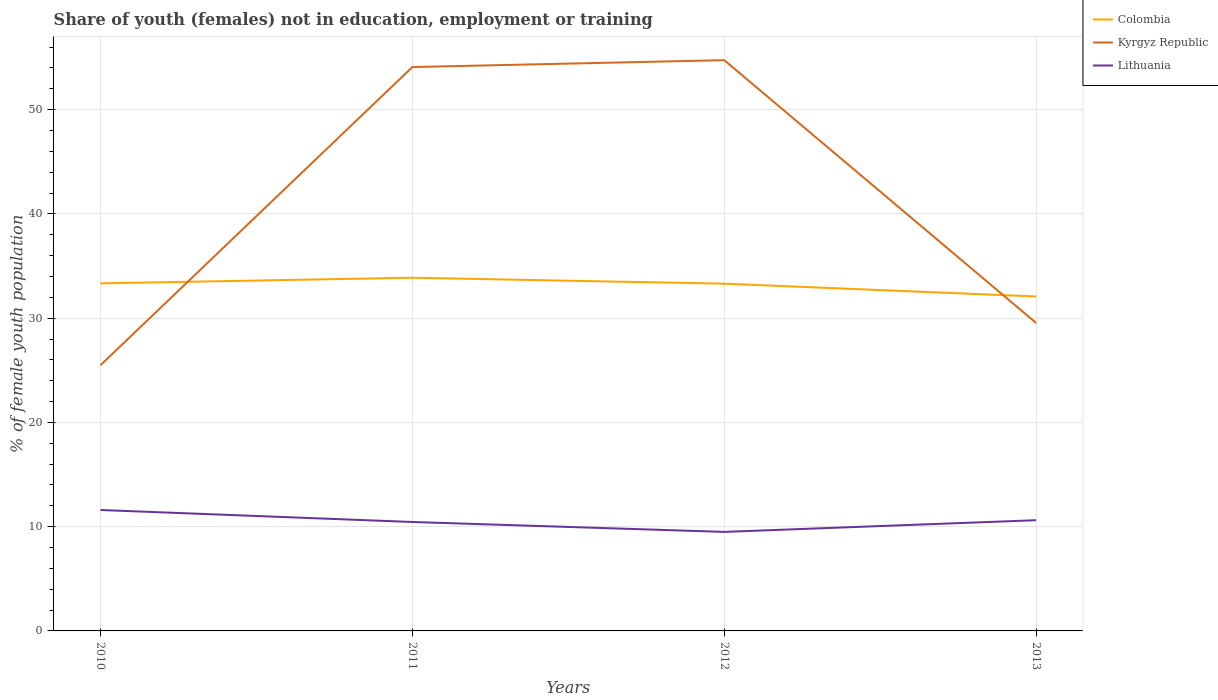How many different coloured lines are there?
Offer a very short reply. 3. Does the line corresponding to Kyrgyz Republic intersect with the line corresponding to Colombia?
Keep it short and to the point. Yes. Is the number of lines equal to the number of legend labels?
Your answer should be very brief. Yes. What is the total percentage of unemployed female population in in Lithuania in the graph?
Your answer should be compact. 1.15. What is the difference between the highest and the second highest percentage of unemployed female population in in Colombia?
Your response must be concise. 1.8. How many years are there in the graph?
Give a very brief answer. 4. Does the graph contain grids?
Offer a very short reply. Yes. How many legend labels are there?
Provide a succinct answer. 3. What is the title of the graph?
Your answer should be compact. Share of youth (females) not in education, employment or training. Does "Sweden" appear as one of the legend labels in the graph?
Your answer should be compact. No. What is the label or title of the Y-axis?
Ensure brevity in your answer.  % of female youth population. What is the % of female youth population of Colombia in 2010?
Offer a very short reply. 33.34. What is the % of female youth population in Kyrgyz Republic in 2010?
Give a very brief answer. 25.49. What is the % of female youth population in Lithuania in 2010?
Provide a succinct answer. 11.6. What is the % of female youth population in Colombia in 2011?
Keep it short and to the point. 33.88. What is the % of female youth population of Kyrgyz Republic in 2011?
Keep it short and to the point. 54.09. What is the % of female youth population of Lithuania in 2011?
Ensure brevity in your answer.  10.45. What is the % of female youth population of Colombia in 2012?
Provide a short and direct response. 33.31. What is the % of female youth population of Kyrgyz Republic in 2012?
Give a very brief answer. 54.75. What is the % of female youth population in Lithuania in 2012?
Offer a very short reply. 9.5. What is the % of female youth population in Colombia in 2013?
Your answer should be compact. 32.08. What is the % of female youth population in Kyrgyz Republic in 2013?
Your answer should be very brief. 29.54. What is the % of female youth population of Lithuania in 2013?
Keep it short and to the point. 10.62. Across all years, what is the maximum % of female youth population of Colombia?
Ensure brevity in your answer.  33.88. Across all years, what is the maximum % of female youth population of Kyrgyz Republic?
Provide a short and direct response. 54.75. Across all years, what is the maximum % of female youth population of Lithuania?
Keep it short and to the point. 11.6. Across all years, what is the minimum % of female youth population of Colombia?
Your answer should be compact. 32.08. Across all years, what is the minimum % of female youth population of Kyrgyz Republic?
Offer a terse response. 25.49. Across all years, what is the minimum % of female youth population in Lithuania?
Your response must be concise. 9.5. What is the total % of female youth population of Colombia in the graph?
Give a very brief answer. 132.61. What is the total % of female youth population in Kyrgyz Republic in the graph?
Provide a succinct answer. 163.87. What is the total % of female youth population of Lithuania in the graph?
Make the answer very short. 42.17. What is the difference between the % of female youth population in Colombia in 2010 and that in 2011?
Make the answer very short. -0.54. What is the difference between the % of female youth population in Kyrgyz Republic in 2010 and that in 2011?
Give a very brief answer. -28.6. What is the difference between the % of female youth population of Lithuania in 2010 and that in 2011?
Make the answer very short. 1.15. What is the difference between the % of female youth population of Colombia in 2010 and that in 2012?
Provide a short and direct response. 0.03. What is the difference between the % of female youth population of Kyrgyz Republic in 2010 and that in 2012?
Make the answer very short. -29.26. What is the difference between the % of female youth population of Lithuania in 2010 and that in 2012?
Offer a terse response. 2.1. What is the difference between the % of female youth population of Colombia in 2010 and that in 2013?
Offer a terse response. 1.26. What is the difference between the % of female youth population of Kyrgyz Republic in 2010 and that in 2013?
Your response must be concise. -4.05. What is the difference between the % of female youth population of Lithuania in 2010 and that in 2013?
Your response must be concise. 0.98. What is the difference between the % of female youth population in Colombia in 2011 and that in 2012?
Keep it short and to the point. 0.57. What is the difference between the % of female youth population in Kyrgyz Republic in 2011 and that in 2012?
Make the answer very short. -0.66. What is the difference between the % of female youth population of Lithuania in 2011 and that in 2012?
Your answer should be compact. 0.95. What is the difference between the % of female youth population of Kyrgyz Republic in 2011 and that in 2013?
Keep it short and to the point. 24.55. What is the difference between the % of female youth population in Lithuania in 2011 and that in 2013?
Your answer should be very brief. -0.17. What is the difference between the % of female youth population in Colombia in 2012 and that in 2013?
Offer a terse response. 1.23. What is the difference between the % of female youth population of Kyrgyz Republic in 2012 and that in 2013?
Your response must be concise. 25.21. What is the difference between the % of female youth population of Lithuania in 2012 and that in 2013?
Your answer should be compact. -1.12. What is the difference between the % of female youth population in Colombia in 2010 and the % of female youth population in Kyrgyz Republic in 2011?
Give a very brief answer. -20.75. What is the difference between the % of female youth population in Colombia in 2010 and the % of female youth population in Lithuania in 2011?
Provide a succinct answer. 22.89. What is the difference between the % of female youth population in Kyrgyz Republic in 2010 and the % of female youth population in Lithuania in 2011?
Your answer should be very brief. 15.04. What is the difference between the % of female youth population of Colombia in 2010 and the % of female youth population of Kyrgyz Republic in 2012?
Keep it short and to the point. -21.41. What is the difference between the % of female youth population of Colombia in 2010 and the % of female youth population of Lithuania in 2012?
Provide a short and direct response. 23.84. What is the difference between the % of female youth population in Kyrgyz Republic in 2010 and the % of female youth population in Lithuania in 2012?
Keep it short and to the point. 15.99. What is the difference between the % of female youth population in Colombia in 2010 and the % of female youth population in Lithuania in 2013?
Offer a very short reply. 22.72. What is the difference between the % of female youth population of Kyrgyz Republic in 2010 and the % of female youth population of Lithuania in 2013?
Provide a short and direct response. 14.87. What is the difference between the % of female youth population in Colombia in 2011 and the % of female youth population in Kyrgyz Republic in 2012?
Your answer should be very brief. -20.87. What is the difference between the % of female youth population in Colombia in 2011 and the % of female youth population in Lithuania in 2012?
Offer a very short reply. 24.38. What is the difference between the % of female youth population of Kyrgyz Republic in 2011 and the % of female youth population of Lithuania in 2012?
Offer a very short reply. 44.59. What is the difference between the % of female youth population of Colombia in 2011 and the % of female youth population of Kyrgyz Republic in 2013?
Your answer should be very brief. 4.34. What is the difference between the % of female youth population of Colombia in 2011 and the % of female youth population of Lithuania in 2013?
Your answer should be very brief. 23.26. What is the difference between the % of female youth population of Kyrgyz Republic in 2011 and the % of female youth population of Lithuania in 2013?
Keep it short and to the point. 43.47. What is the difference between the % of female youth population of Colombia in 2012 and the % of female youth population of Kyrgyz Republic in 2013?
Keep it short and to the point. 3.77. What is the difference between the % of female youth population of Colombia in 2012 and the % of female youth population of Lithuania in 2013?
Your answer should be compact. 22.69. What is the difference between the % of female youth population in Kyrgyz Republic in 2012 and the % of female youth population in Lithuania in 2013?
Ensure brevity in your answer.  44.13. What is the average % of female youth population of Colombia per year?
Your answer should be very brief. 33.15. What is the average % of female youth population in Kyrgyz Republic per year?
Ensure brevity in your answer.  40.97. What is the average % of female youth population in Lithuania per year?
Offer a terse response. 10.54. In the year 2010, what is the difference between the % of female youth population in Colombia and % of female youth population in Kyrgyz Republic?
Make the answer very short. 7.85. In the year 2010, what is the difference between the % of female youth population of Colombia and % of female youth population of Lithuania?
Ensure brevity in your answer.  21.74. In the year 2010, what is the difference between the % of female youth population in Kyrgyz Republic and % of female youth population in Lithuania?
Your answer should be compact. 13.89. In the year 2011, what is the difference between the % of female youth population in Colombia and % of female youth population in Kyrgyz Republic?
Provide a succinct answer. -20.21. In the year 2011, what is the difference between the % of female youth population of Colombia and % of female youth population of Lithuania?
Provide a succinct answer. 23.43. In the year 2011, what is the difference between the % of female youth population in Kyrgyz Republic and % of female youth population in Lithuania?
Provide a succinct answer. 43.64. In the year 2012, what is the difference between the % of female youth population of Colombia and % of female youth population of Kyrgyz Republic?
Give a very brief answer. -21.44. In the year 2012, what is the difference between the % of female youth population in Colombia and % of female youth population in Lithuania?
Your answer should be compact. 23.81. In the year 2012, what is the difference between the % of female youth population of Kyrgyz Republic and % of female youth population of Lithuania?
Make the answer very short. 45.25. In the year 2013, what is the difference between the % of female youth population in Colombia and % of female youth population in Kyrgyz Republic?
Provide a succinct answer. 2.54. In the year 2013, what is the difference between the % of female youth population of Colombia and % of female youth population of Lithuania?
Provide a short and direct response. 21.46. In the year 2013, what is the difference between the % of female youth population of Kyrgyz Republic and % of female youth population of Lithuania?
Provide a short and direct response. 18.92. What is the ratio of the % of female youth population in Colombia in 2010 to that in 2011?
Give a very brief answer. 0.98. What is the ratio of the % of female youth population of Kyrgyz Republic in 2010 to that in 2011?
Your answer should be compact. 0.47. What is the ratio of the % of female youth population of Lithuania in 2010 to that in 2011?
Provide a succinct answer. 1.11. What is the ratio of the % of female youth population in Colombia in 2010 to that in 2012?
Provide a succinct answer. 1. What is the ratio of the % of female youth population in Kyrgyz Republic in 2010 to that in 2012?
Your response must be concise. 0.47. What is the ratio of the % of female youth population in Lithuania in 2010 to that in 2012?
Ensure brevity in your answer.  1.22. What is the ratio of the % of female youth population in Colombia in 2010 to that in 2013?
Your answer should be very brief. 1.04. What is the ratio of the % of female youth population in Kyrgyz Republic in 2010 to that in 2013?
Provide a succinct answer. 0.86. What is the ratio of the % of female youth population of Lithuania in 2010 to that in 2013?
Keep it short and to the point. 1.09. What is the ratio of the % of female youth population of Colombia in 2011 to that in 2012?
Your answer should be very brief. 1.02. What is the ratio of the % of female youth population of Kyrgyz Republic in 2011 to that in 2012?
Offer a very short reply. 0.99. What is the ratio of the % of female youth population in Lithuania in 2011 to that in 2012?
Give a very brief answer. 1.1. What is the ratio of the % of female youth population in Colombia in 2011 to that in 2013?
Your response must be concise. 1.06. What is the ratio of the % of female youth population of Kyrgyz Republic in 2011 to that in 2013?
Your answer should be very brief. 1.83. What is the ratio of the % of female youth population in Colombia in 2012 to that in 2013?
Keep it short and to the point. 1.04. What is the ratio of the % of female youth population of Kyrgyz Republic in 2012 to that in 2013?
Your answer should be very brief. 1.85. What is the ratio of the % of female youth population in Lithuania in 2012 to that in 2013?
Your response must be concise. 0.89. What is the difference between the highest and the second highest % of female youth population in Colombia?
Your answer should be very brief. 0.54. What is the difference between the highest and the second highest % of female youth population in Kyrgyz Republic?
Give a very brief answer. 0.66. What is the difference between the highest and the second highest % of female youth population of Lithuania?
Ensure brevity in your answer.  0.98. What is the difference between the highest and the lowest % of female youth population of Kyrgyz Republic?
Offer a very short reply. 29.26. What is the difference between the highest and the lowest % of female youth population of Lithuania?
Give a very brief answer. 2.1. 